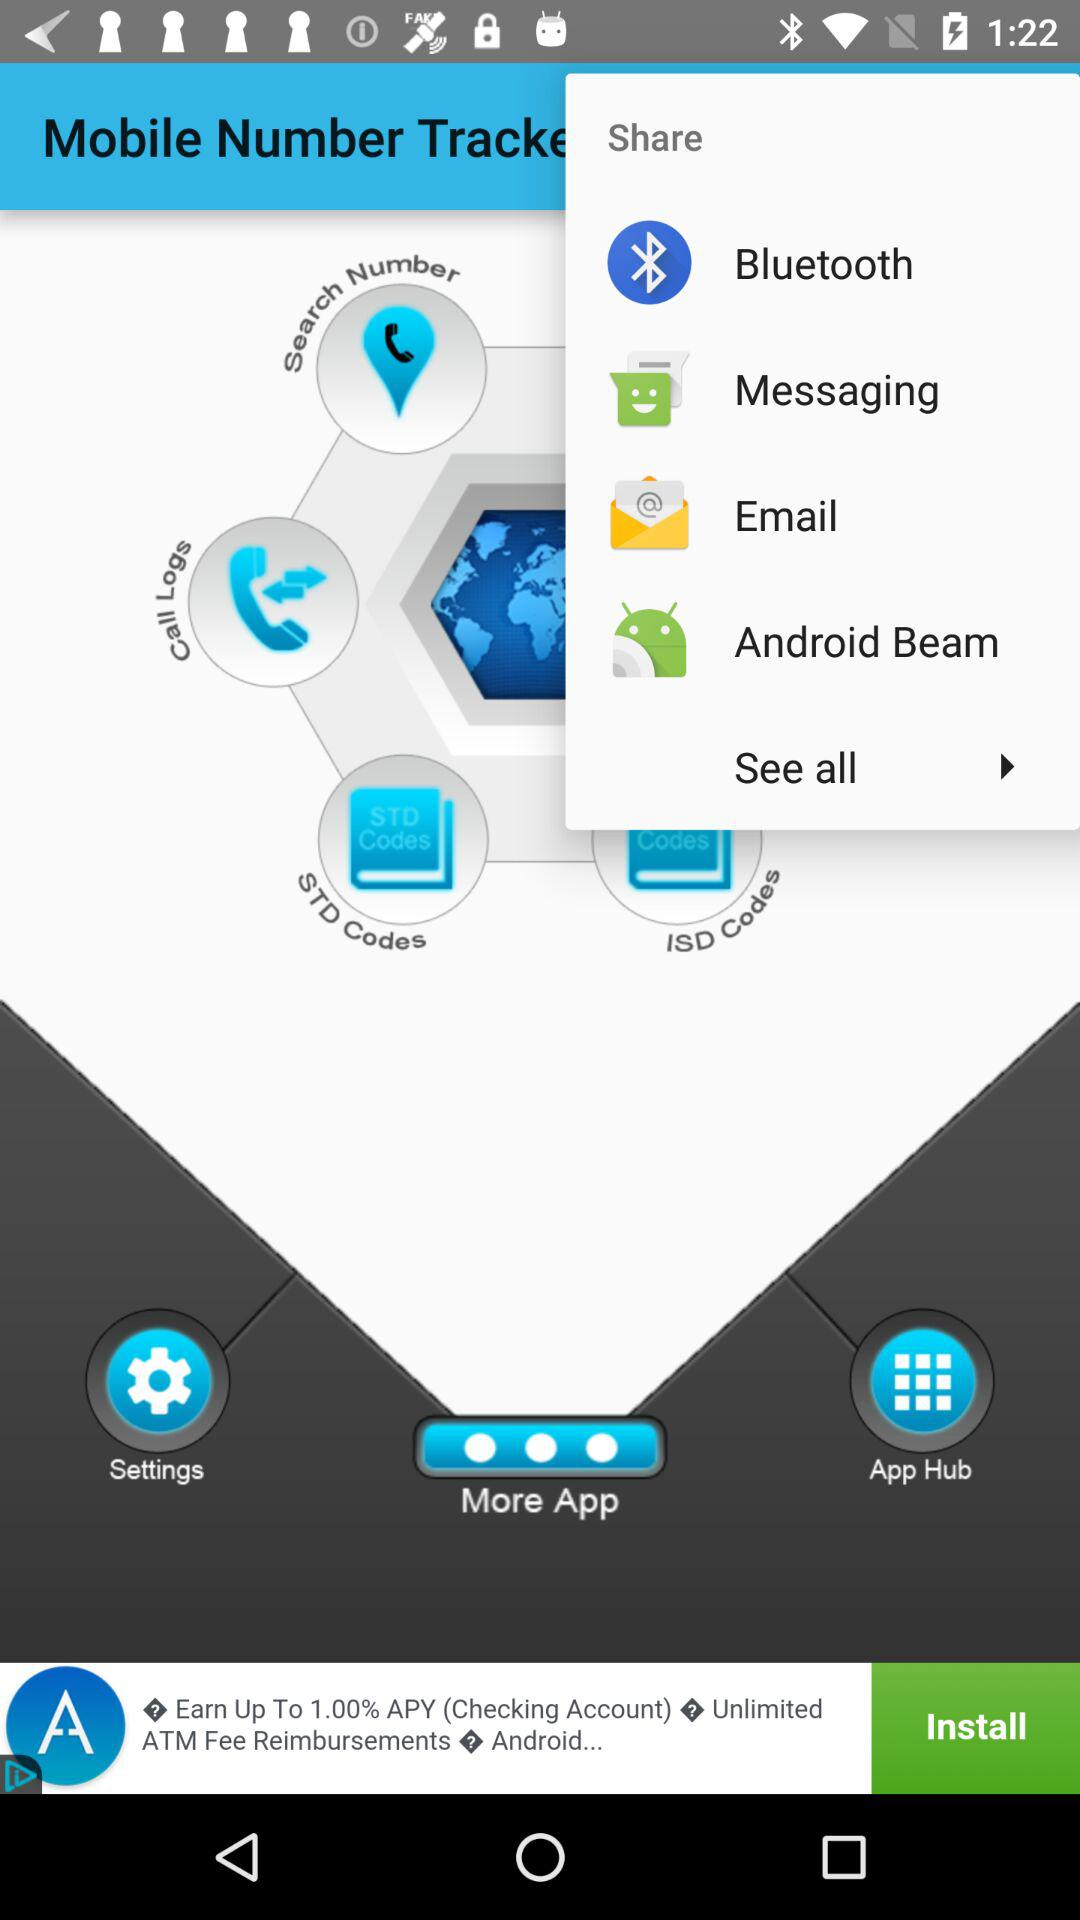What are the different applications through which we can share? The applications are "Bluetooth", "Messaging", "Email" and "Android Beam". 